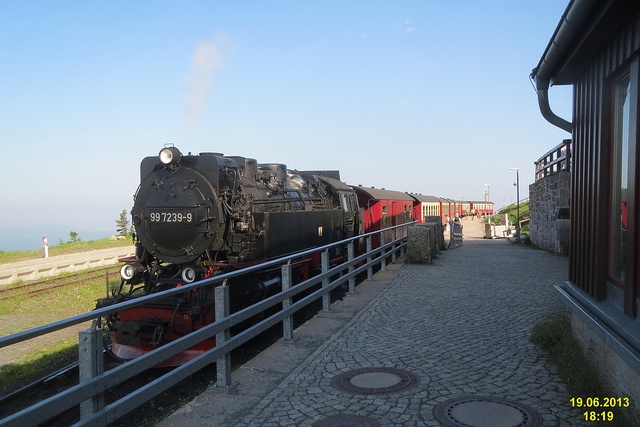Describe the objects in this image and their specific colors. I can see train in lightblue, black, gray, lightgray, and darkgray tones, people in lightblue, lightgray, tan, and salmon tones, people in lightblue, ivory, darkgray, and gray tones, and people in lightblue, khaki, tan, and salmon tones in this image. 